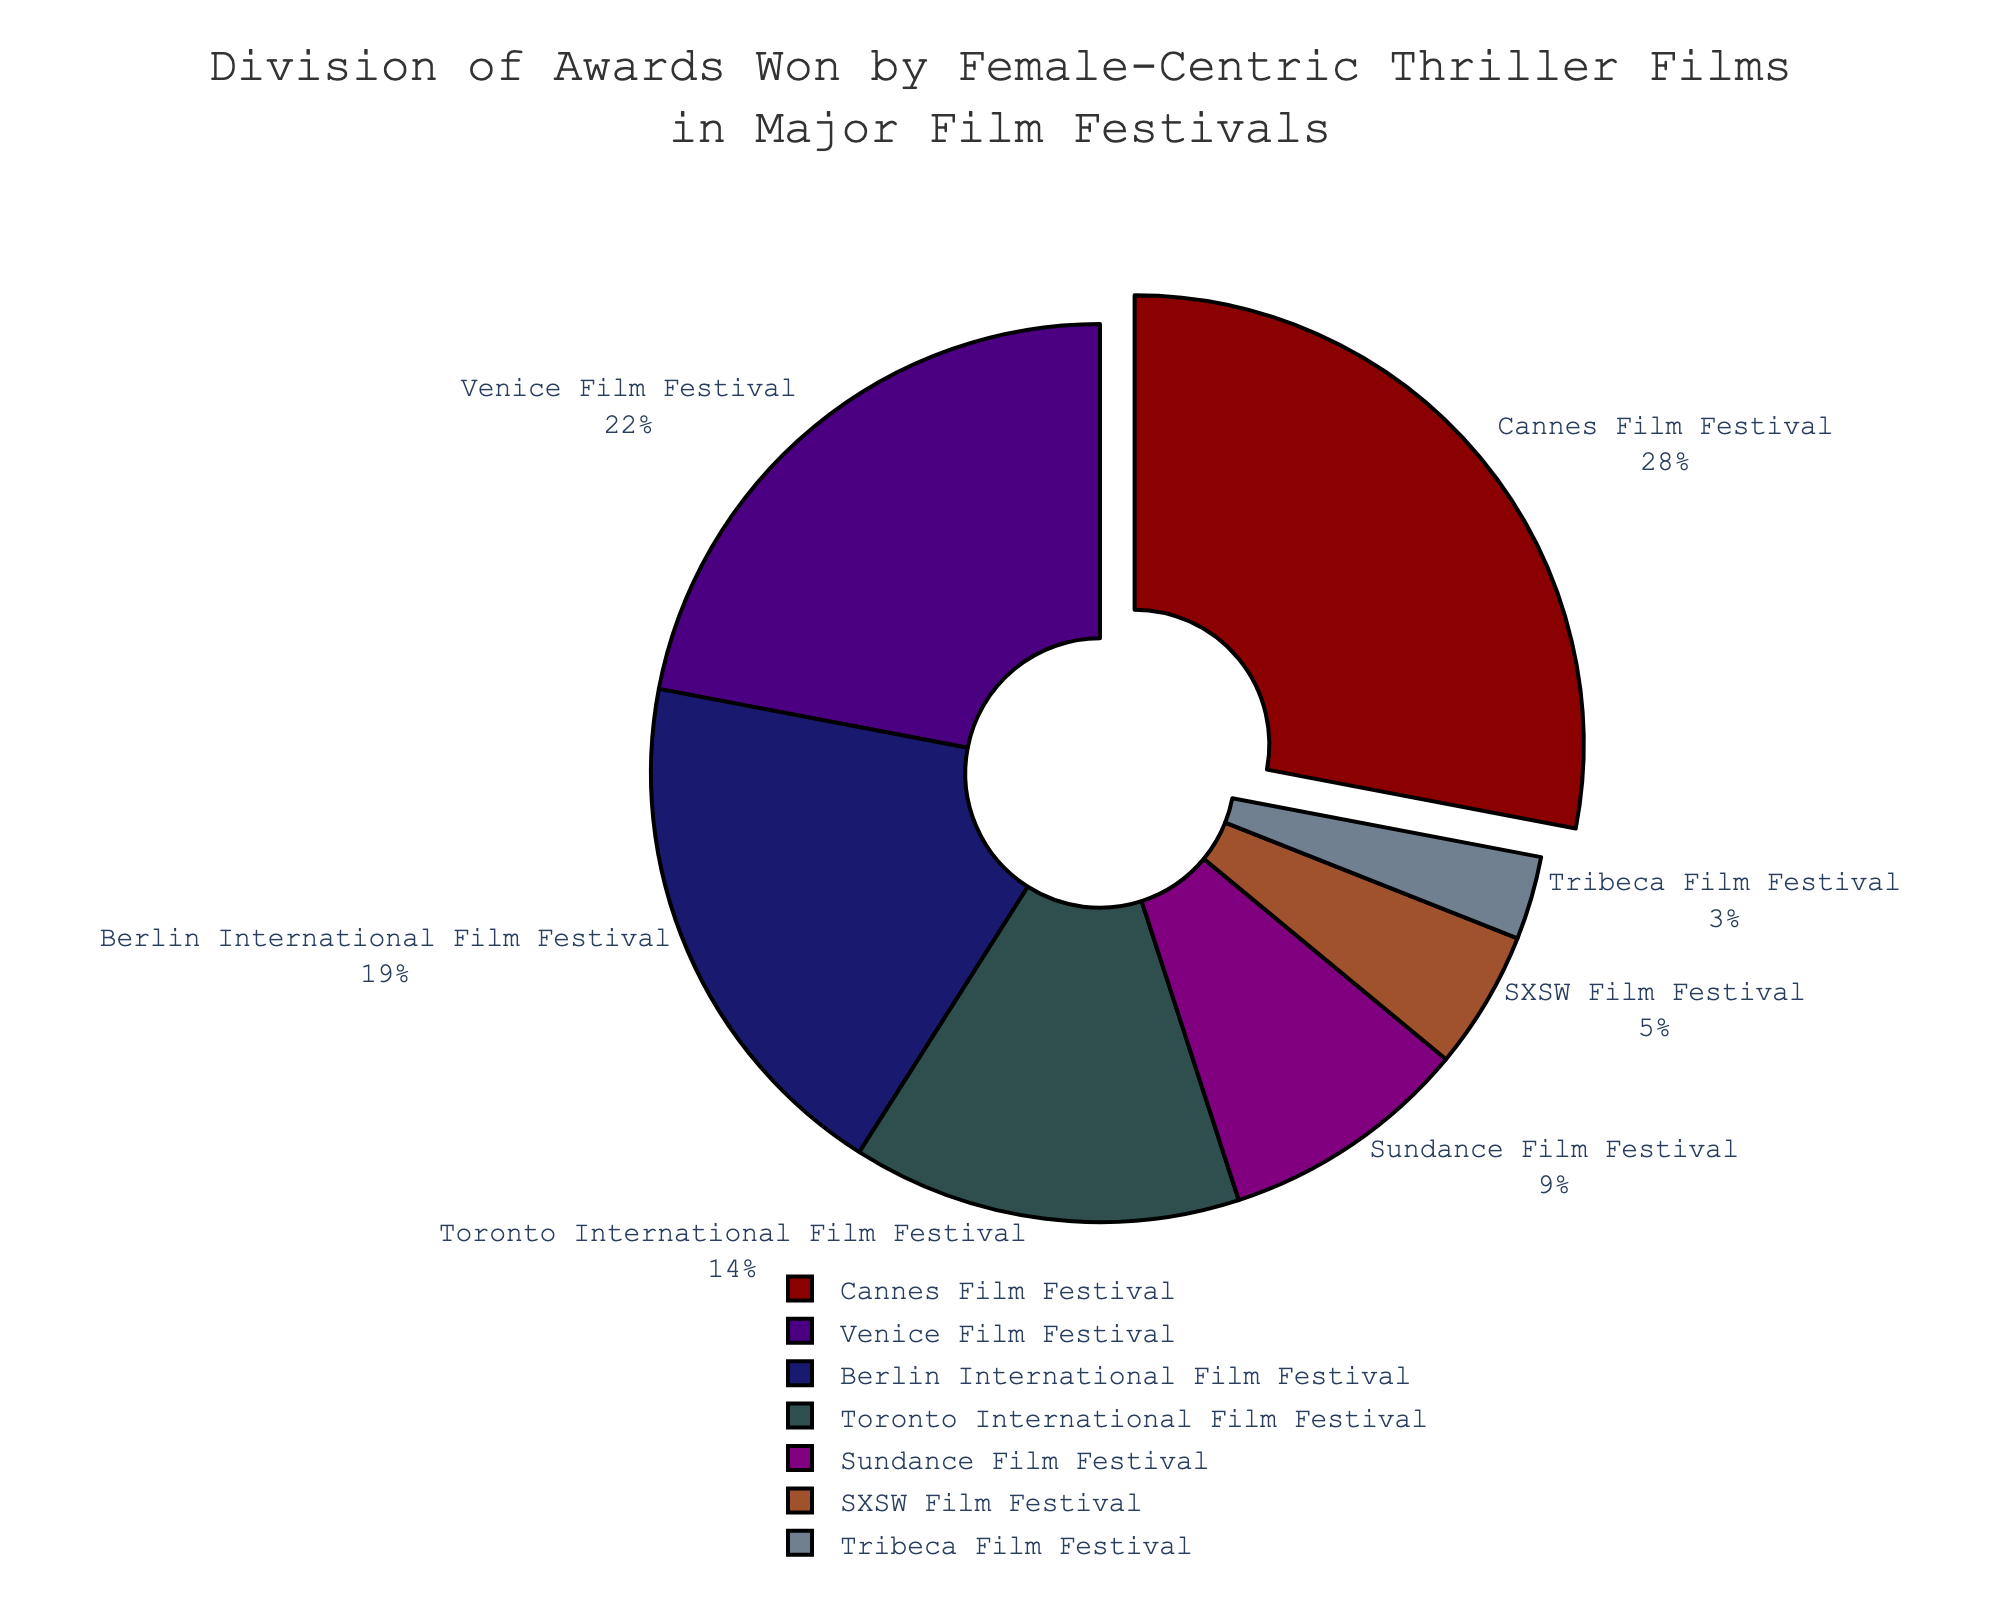What is the festival with the highest percentage of awards won by female-centric thriller films? The pie chart shows the percentages of awards won by female-centric thriller films at various film festivals. The slice labeled "Cannes Film Festival" has the highest percentage at 28%.
Answer: Cannes Film Festival What is the difference in percentage points between the Cannes and Venice Film Festivals? Cannes Film Festival has 28% while Venice Film Festival has 22%. The difference is 28% - 22% = 6%.
Answer: 6% Which film festivals combined account for over 50% of the awards won by female-centric thriller films? The combined percentages for Cannes Film Festival (28%), Venice Film Festival (22%), and Berlin International Film Festival (19%) total to 28% + 22% + 19% = 69%, which is over 50%.
Answer: Cannes, Venice, Berlin What is the total percentage of awards won by female-centric thriller films at the Sundance, SXSW, and Tribeca Film Festivals? The percentages are 9% (Sundance), 5% (SXSW), and 3% (Tribeca). The total is 9% + 5% + 3% = 17%.
Answer: 17% Which festival has the smallest slice in the pie chart and what is its percentage? The smallest slice in the pie chart corresponds to the Tribeca Film Festival, which has a percentage of 3%.
Answer: Tribeca Film Festival, 3% Compare the combined percentage of awards won at the Berlin and Toronto International Film Festivals with the percentage of awards won at the Cannes Film Festival. Berlin International Film Festival has 19% and Toronto International Film Festival has 14%. Combined, they account for 19% + 14% = 33%, which is greater than Cannes’ 28%.
Answer: 33%, greater than Cannes What is the average percentage of awards won at all the listed film festivals? Add the percentages of all listed festivals (28% + 22% + 19% + 14% + 9% + 5% + 3% = 100%) and divide by the number of festivals (7). The average is 100% / 7 ≈ 14.29%.
Answer: 14.29% Which slice is visually pulled outward for emphasis, and what is the percentage of awards it represents? The slice that is visually pulled outward for emphasis is the Cannes Film Festival, which represents 28% of the awards.
Answer: Cannes Film Festival, 28% What is the combined percentage of awards won by female-centric thriller films at the Toronto International Film Festival and SXSW Film Festival as compared to Venice Film Festival alone? Toronto International Film Festival has 14% and SXSW has 5%. Combined, they account for 14% + 5% = 19%, which is less than Venice Film Festival’s 22%.
Answer: 19%, less than Venice 